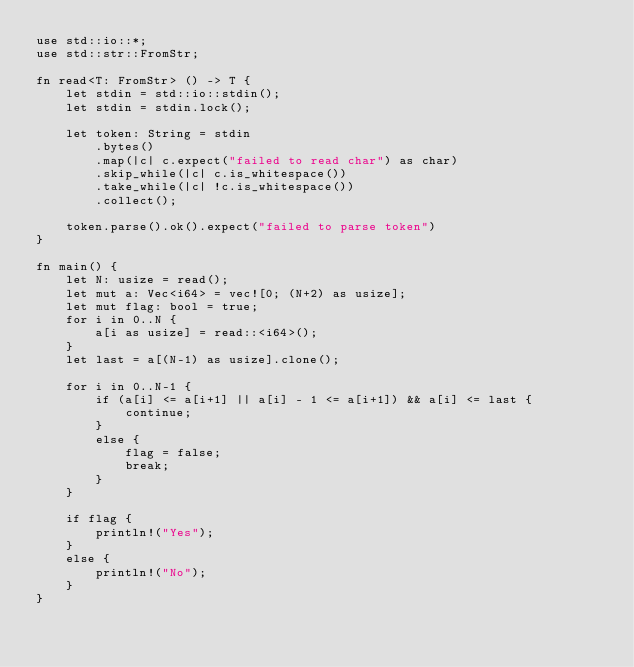Convert code to text. <code><loc_0><loc_0><loc_500><loc_500><_Rust_>use std::io::*;
use std::str::FromStr;

fn read<T: FromStr> () -> T {
    let stdin = std::io::stdin();
    let stdin = stdin.lock();

    let token: String = stdin
        .bytes()
        .map(|c| c.expect("failed to read char") as char)
        .skip_while(|c| c.is_whitespace())
        .take_while(|c| !c.is_whitespace())
        .collect();

    token.parse().ok().expect("failed to parse token")
}

fn main() {
    let N: usize = read();
    let mut a: Vec<i64> = vec![0; (N+2) as usize];
    let mut flag: bool = true;
    for i in 0..N {
        a[i as usize] = read::<i64>();
    }
    let last = a[(N-1) as usize].clone();

    for i in 0..N-1 {
        if (a[i] <= a[i+1] || a[i] - 1 <= a[i+1]) && a[i] <= last {
            continue;
        }
        else {
            flag = false;
            break;
        }
    }

    if flag {
        println!("Yes");
    }
    else {
        println!("No");
    }
}
</code> 